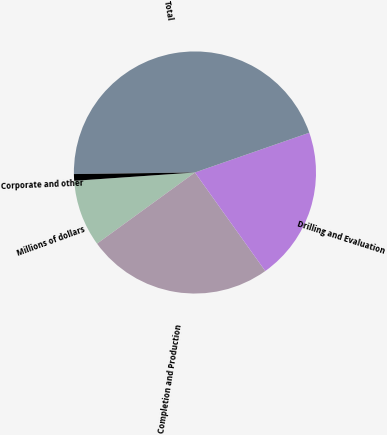<chart> <loc_0><loc_0><loc_500><loc_500><pie_chart><fcel>Millions of dollars<fcel>Completion and Production<fcel>Drilling and Evaluation<fcel>Total<fcel>Corporate and other<nl><fcel>8.91%<fcel>24.86%<fcel>20.46%<fcel>44.88%<fcel>0.89%<nl></chart> 